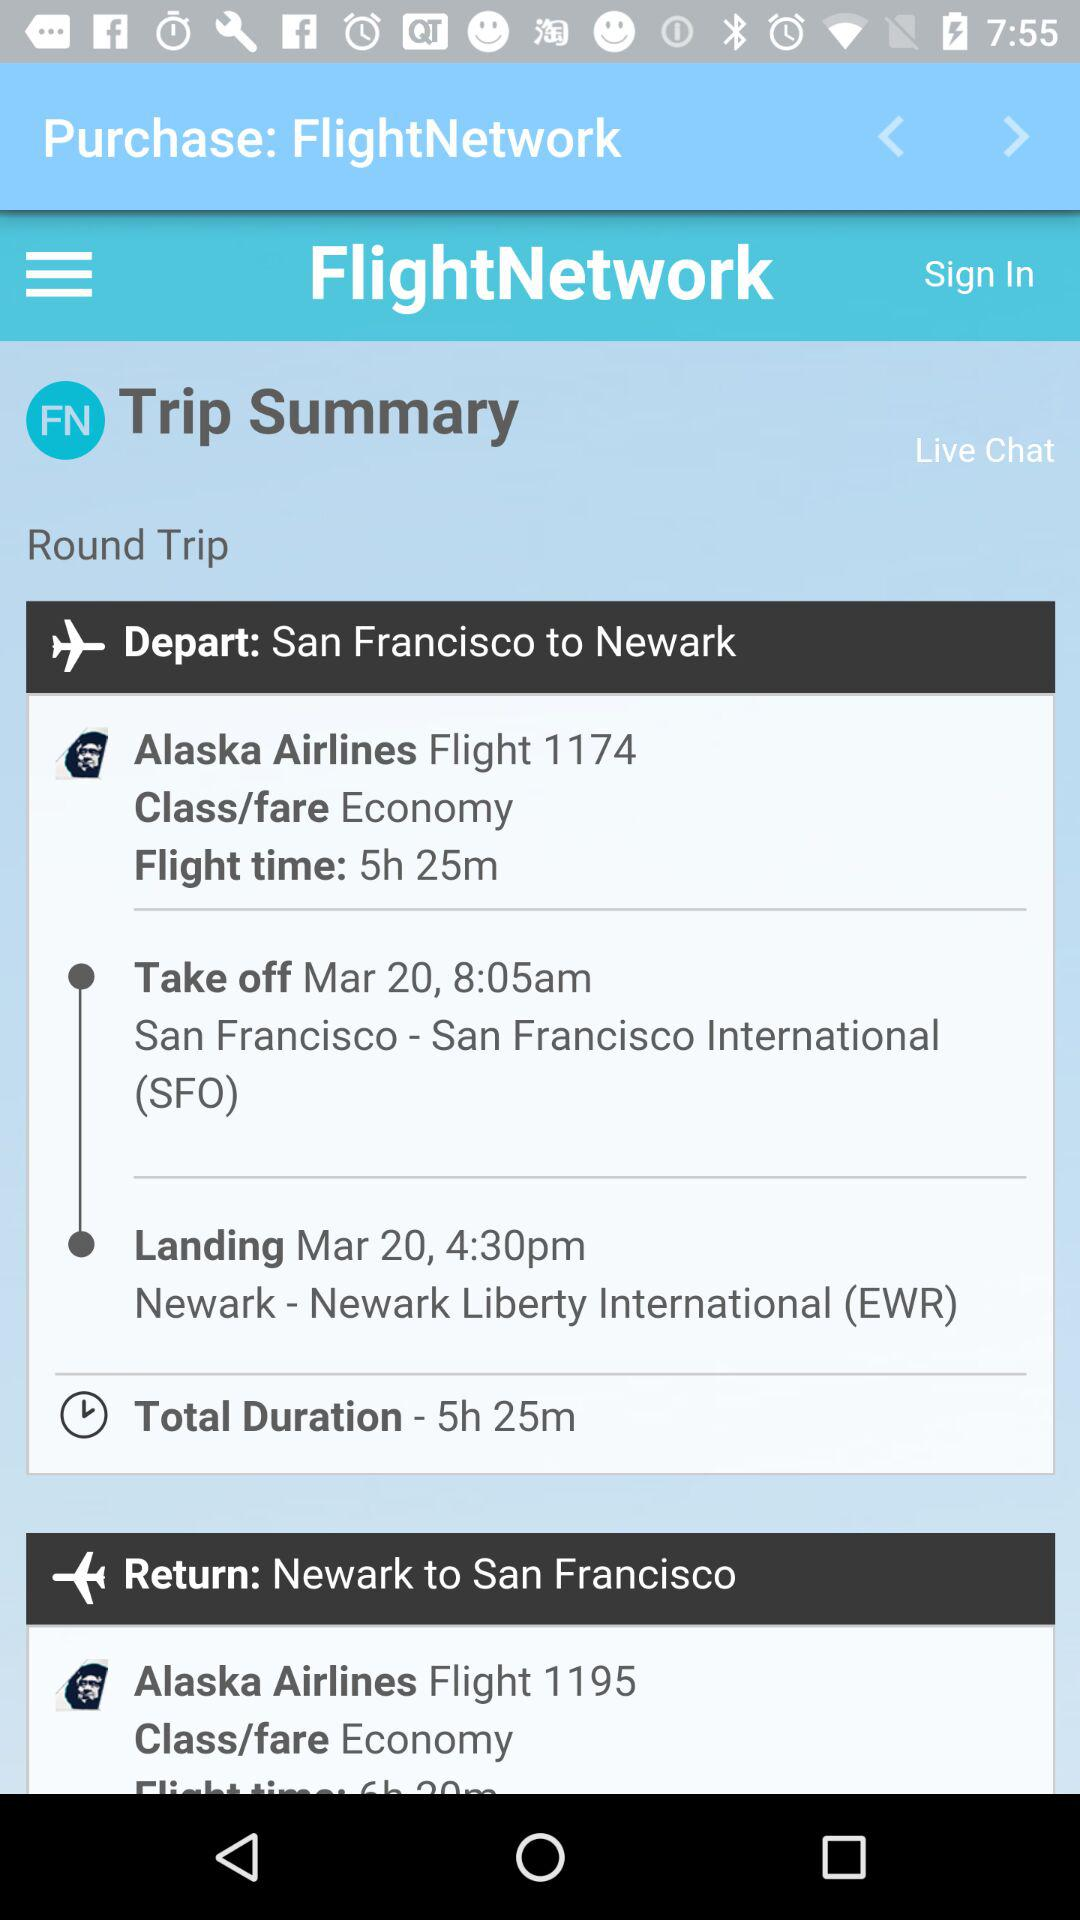What is the flight number from Newark to San Francisco? The flight number from Newark to San Francisco is 1195. 